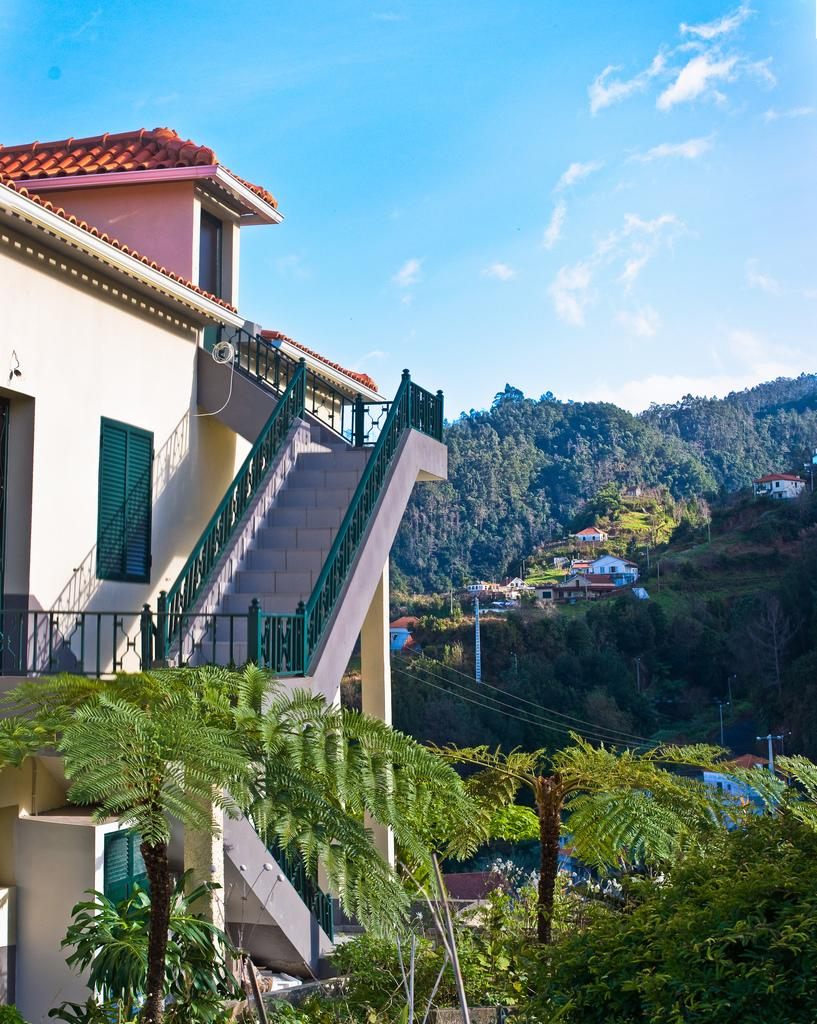What type of natural elements can be seen in the image? There are trees and mountains in the image. What type of man-made structures are present in the image? There are buildings, steps, windows, and poles in the image. What is connecting the poles in the image? There are wires connecting the poles in the image. What can be seen in the background of the image? The sky is visible in the background of the image, with clouds present. Can you tell me how many agreements were signed in the image? There is no mention of any agreements being signed in the image. What color are the robins' eyes in the image? There are no robins present in the image. 